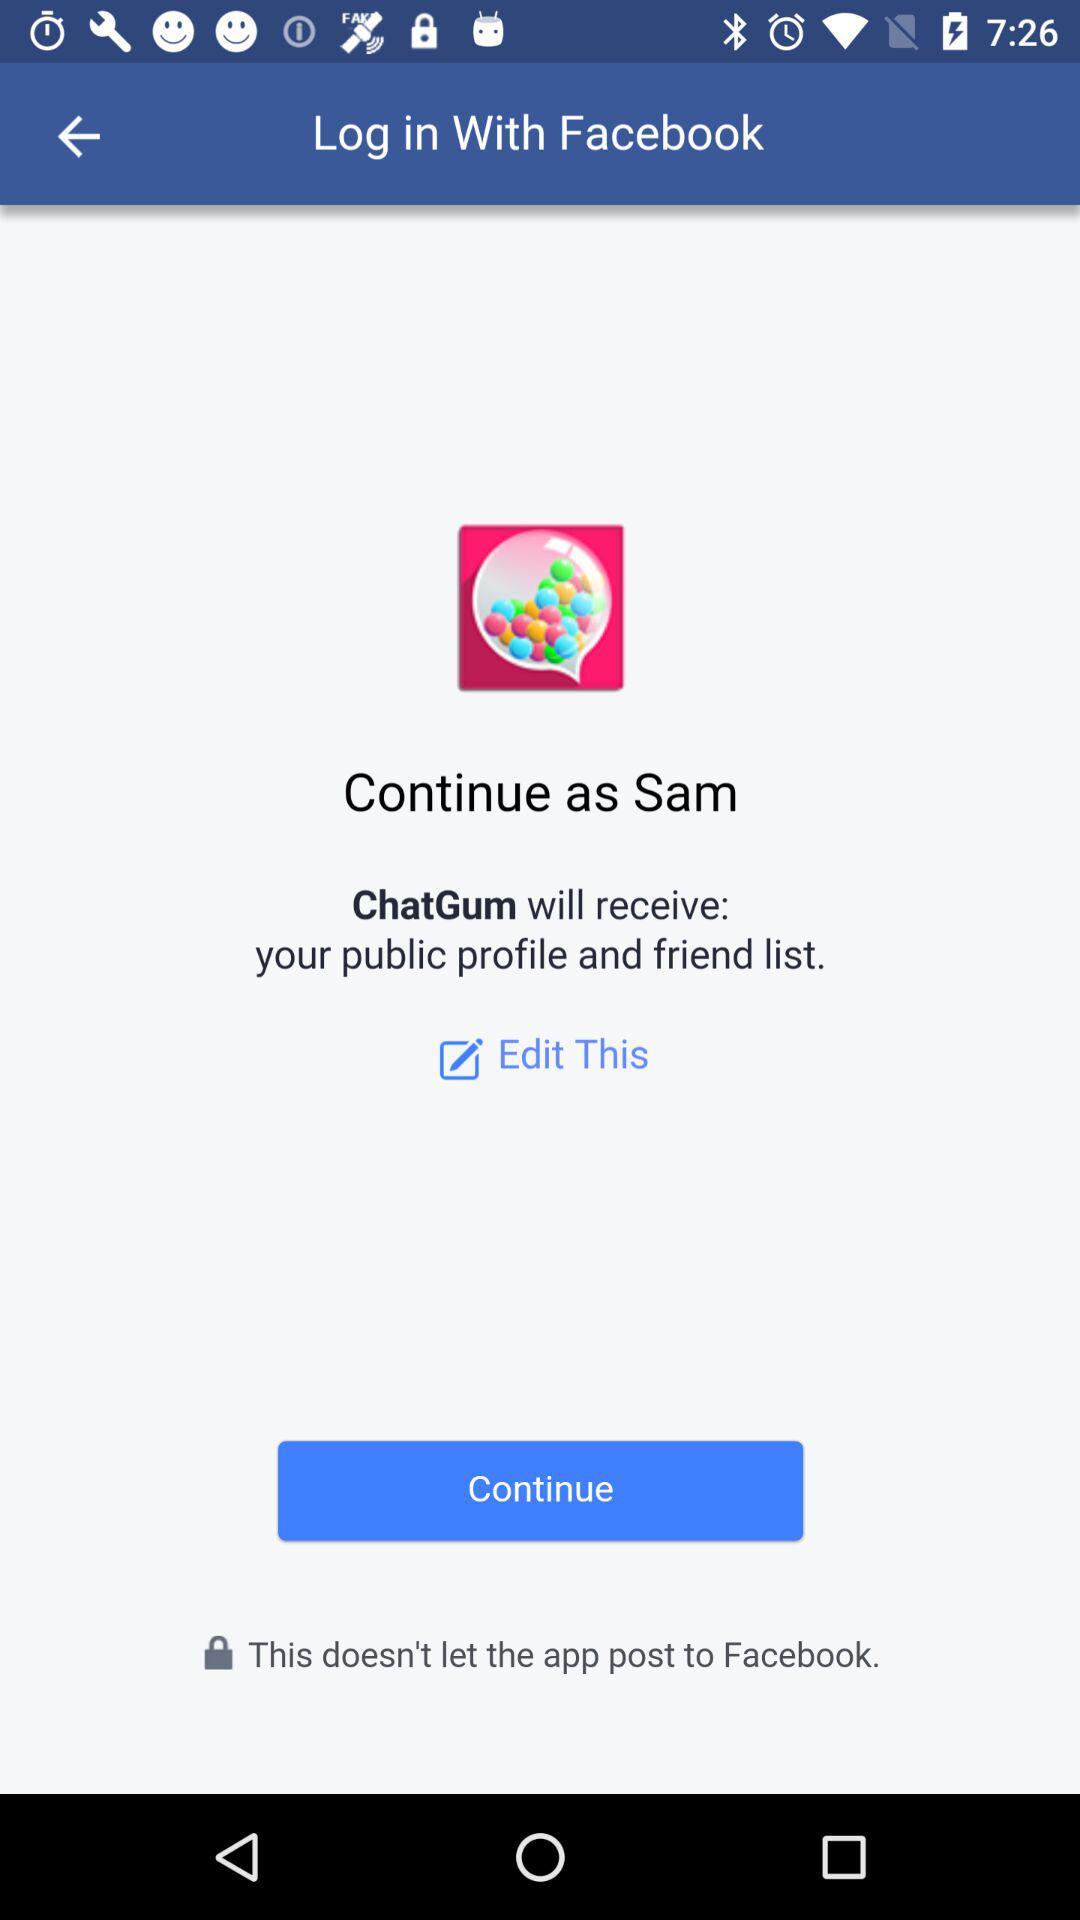Which application is asking for permission? The application that is asking for permission is "ChatGum". 